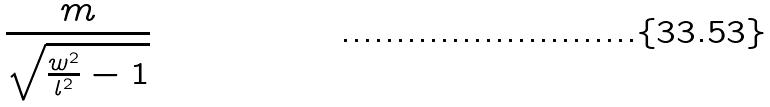Convert formula to latex. <formula><loc_0><loc_0><loc_500><loc_500>\frac { m } { \sqrt { \frac { w ^ { 2 } } { l ^ { 2 } } - 1 } }</formula> 